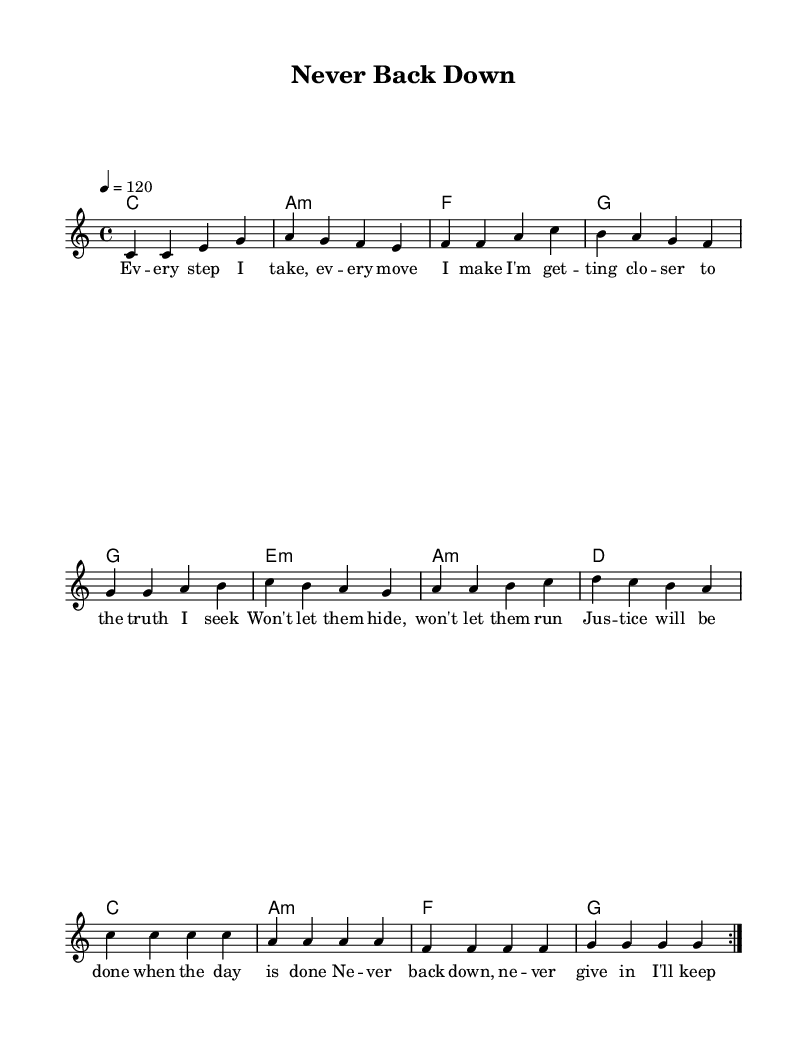What is the key signature of this music? The key signature is C major, which has no sharps or flats.
Answer: C major What is the time signature of this piece? The time signature is indicated at the beginning of the sheet music, and it shows that there are four beats per measure.
Answer: 4/4 What is the tempo marking in this score? The tempo marking indicates a tempo of 120 beats per minute, which is specified in the tempo command.
Answer: 120 How many times is the melody repeated? The repeat markings present in the score indicate that the melody is played twice.
Answer: 2 What are the lyrics for the first line? The first line of lyrics is "Every step I take, every move I make," which can be found under the melody notes.
Answer: Every step I take, every move I make Identify the chord used in the third measure. The chord indicated in the third measure is F major, which corresponds to the symbol under the melody.
Answer: F What is the theme of this piece? The overall theme can be discerned from the lyrics and message conveyed within the music, which focuses on persistence and determination.
Answer: Persistence 